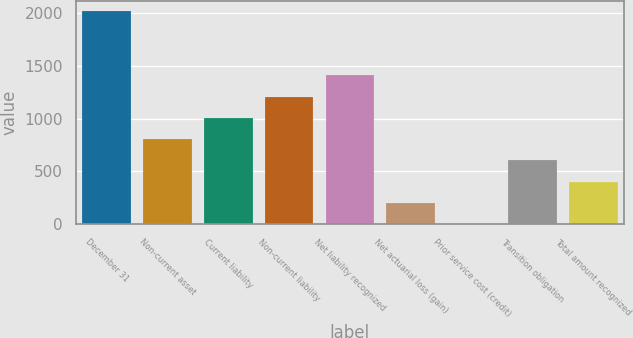Convert chart to OTSL. <chart><loc_0><loc_0><loc_500><loc_500><bar_chart><fcel>December 31<fcel>Non-current asset<fcel>Current liability<fcel>Non-current liability<fcel>Net liability recognized<fcel>Net actuarial loss (gain)<fcel>Prior service cost (credit)<fcel>Transition obligation<fcel>Total amount recognized<nl><fcel>2013<fcel>805.26<fcel>1006.55<fcel>1207.84<fcel>1409.13<fcel>201.39<fcel>0.1<fcel>603.97<fcel>402.68<nl></chart> 